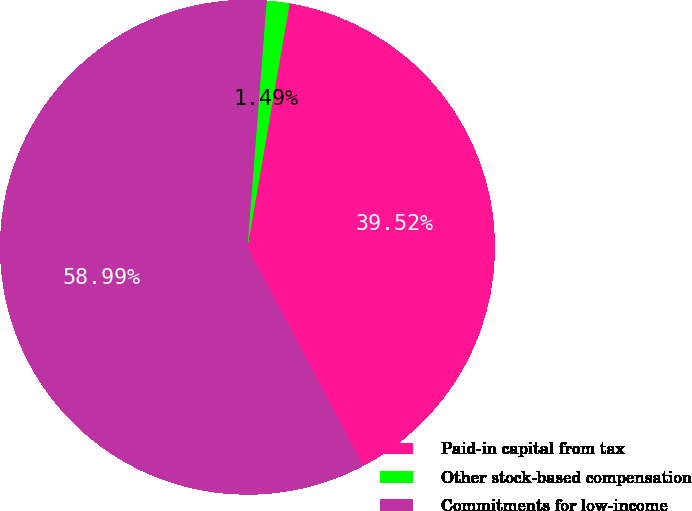Convert chart. <chart><loc_0><loc_0><loc_500><loc_500><pie_chart><fcel>Paid-in capital from tax<fcel>Other stock-based compensation<fcel>Commitments for low-income<nl><fcel>39.52%<fcel>1.49%<fcel>58.99%<nl></chart> 